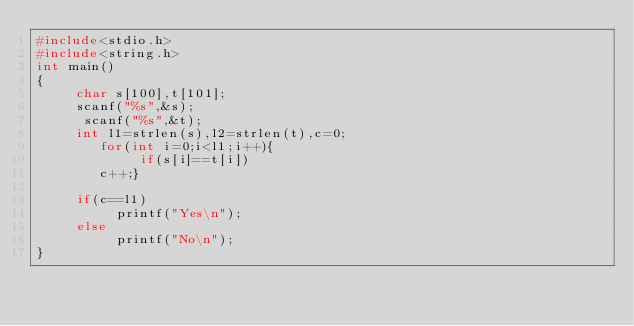Convert code to text. <code><loc_0><loc_0><loc_500><loc_500><_C_>#include<stdio.h>
#include<string.h>
int main()
{
     char s[100],t[101];
     scanf("%s",&s);
      scanf("%s",&t);
     int l1=strlen(s),l2=strlen(t),c=0;
        for(int i=0;i<l1;i++){
             if(s[i]==t[i])
        c++;}

     if(c==l1)
          printf("Yes\n");
     else
          printf("No\n");
}
</code> 